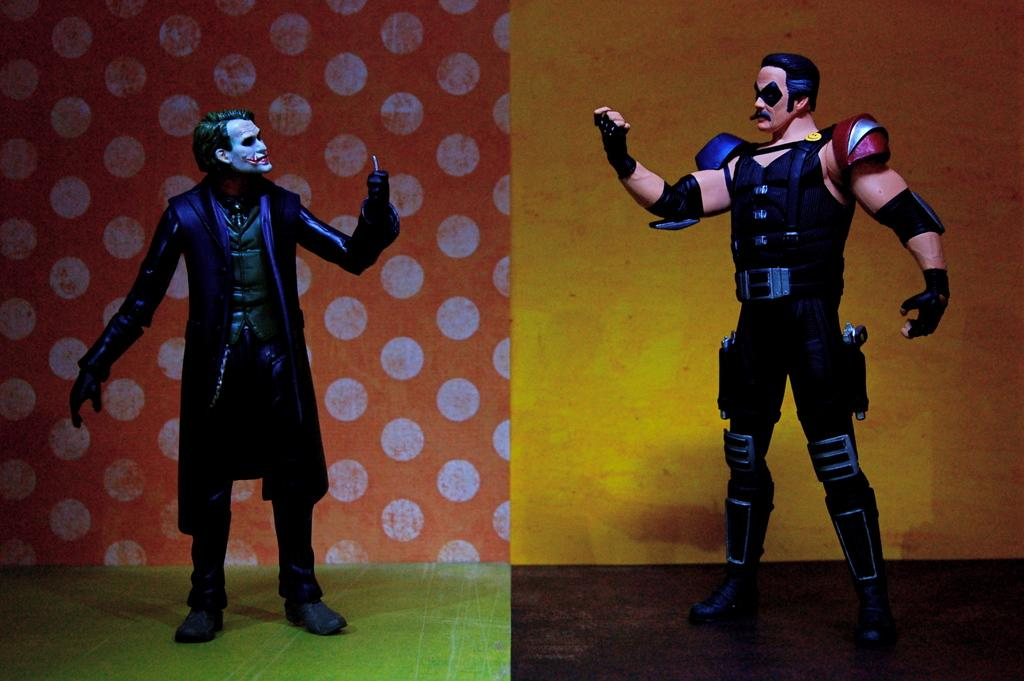What type of artwork is the image? The image is a collage. How many people are in the image? There are two men in the image. What are the men wearing? The men are wearing costumes. What type of surface are the men standing on? The men are standing on floors. What can be seen in the background of the image? There are walls visible in the background of the image. What time of day is the operation taking place in the image? There is no operation present in the image, and therefore no specific time of day can be determined. 